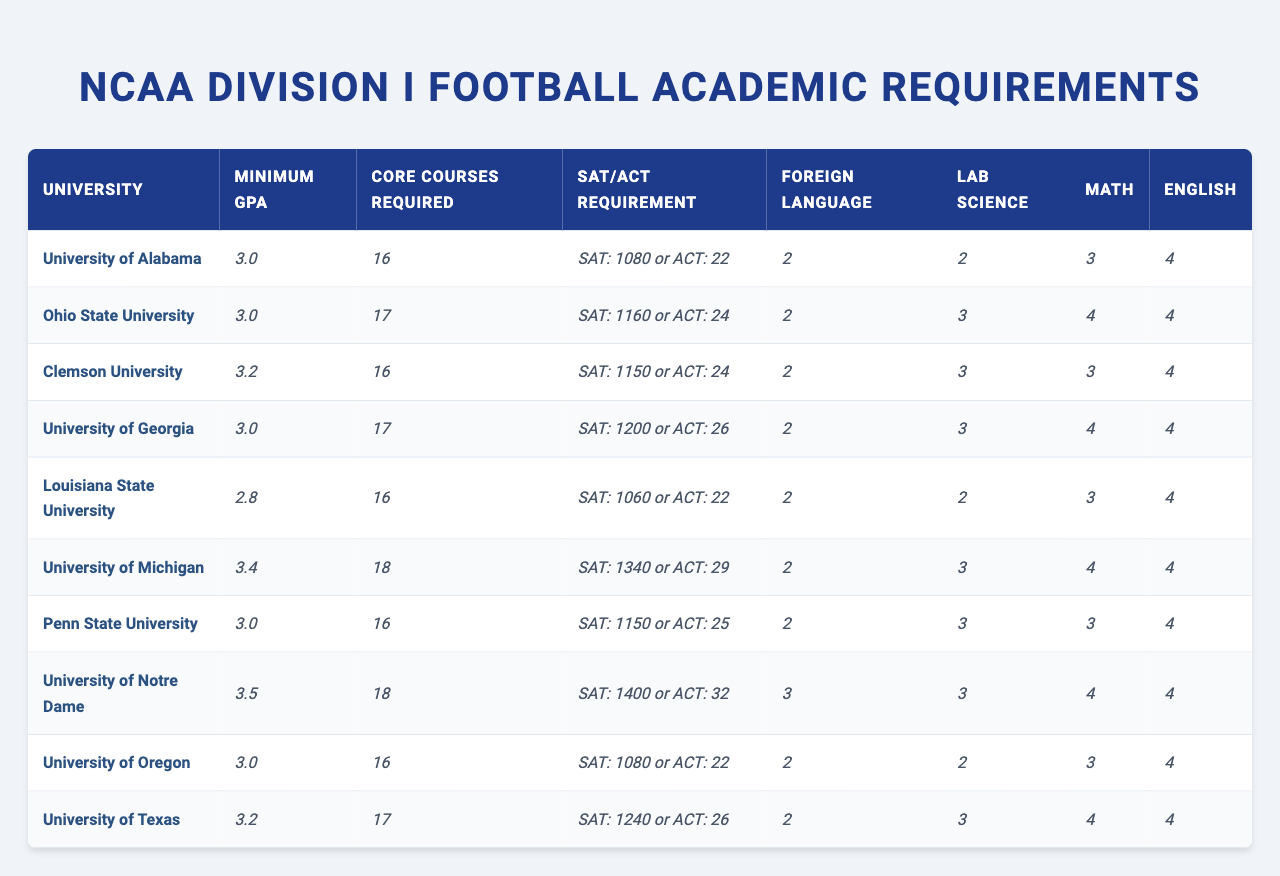What is the minimum GPA required by the University of Michigan? The table shows that the University of Michigan requires a minimum GPA of 3.4.
Answer: 3.4 How many core courses are required by Ohio State University? According to the table, Ohio State University requires 17 core courses.
Answer: 17 Does Louisiana State University require lab science as part of its academic requirements? The table indicates that Louisiana State University requires 2 lab science courses, thus it does require lab science.
Answer: Yes Which university has the highest minimum GPA requirement? From the data, the University of Notre Dame has the highest minimum GPA at 3.5.
Answer: University of Notre Dame What is the average number of core courses required across all listed universities? Adding the core course requirements (16 + 17 + 16 + 17 + 16 + 18 + 16 + 18 + 16 + 17) = 168. There are 10 universities, so the average is 168/10 = 16.8.
Answer: 16.8 How many universities require a minimum GPA of 3.0 or higher? The universities that require a minimum GPA of 3.0 or higher are the University of Alabama, Ohio State University, Clemson University, University of Georgia, University of Michigan, Penn State University, University of Notre Dame, and University of Texas. This totals to 8 universities.
Answer: 8 Which university has the lowest lab science requirement, and what is it? The table shows that Louisiana State University and the University of Oregon both require only 2 lab science courses, which is the lowest.
Answer: Louisiana State University and University of Oregon If a student scored 1100 on the SAT, which universities would they qualify for? Looking at the table, a score of 1100 meets the SAT requirement for the University of Alabama (SAT: 1080) and the University of Oregon (SAT: 1080).
Answer: University of Alabama and University of Oregon Are there any universities that require only 2 foreign language courses? The table indicates that the University of Alabama, Louisiana State University, and the University of Oregon each require only 2 foreign language courses.
Answer: Yes What is the difference in the minimum GPA requirement between the University of Michigan and Louisiana State University? The University of Michigan has a minimum GPA of 3.4 and Louisiana State University has a minimum GPA of 2.8. The difference is 3.4 - 2.8 = 0.6.
Answer: 0.6 